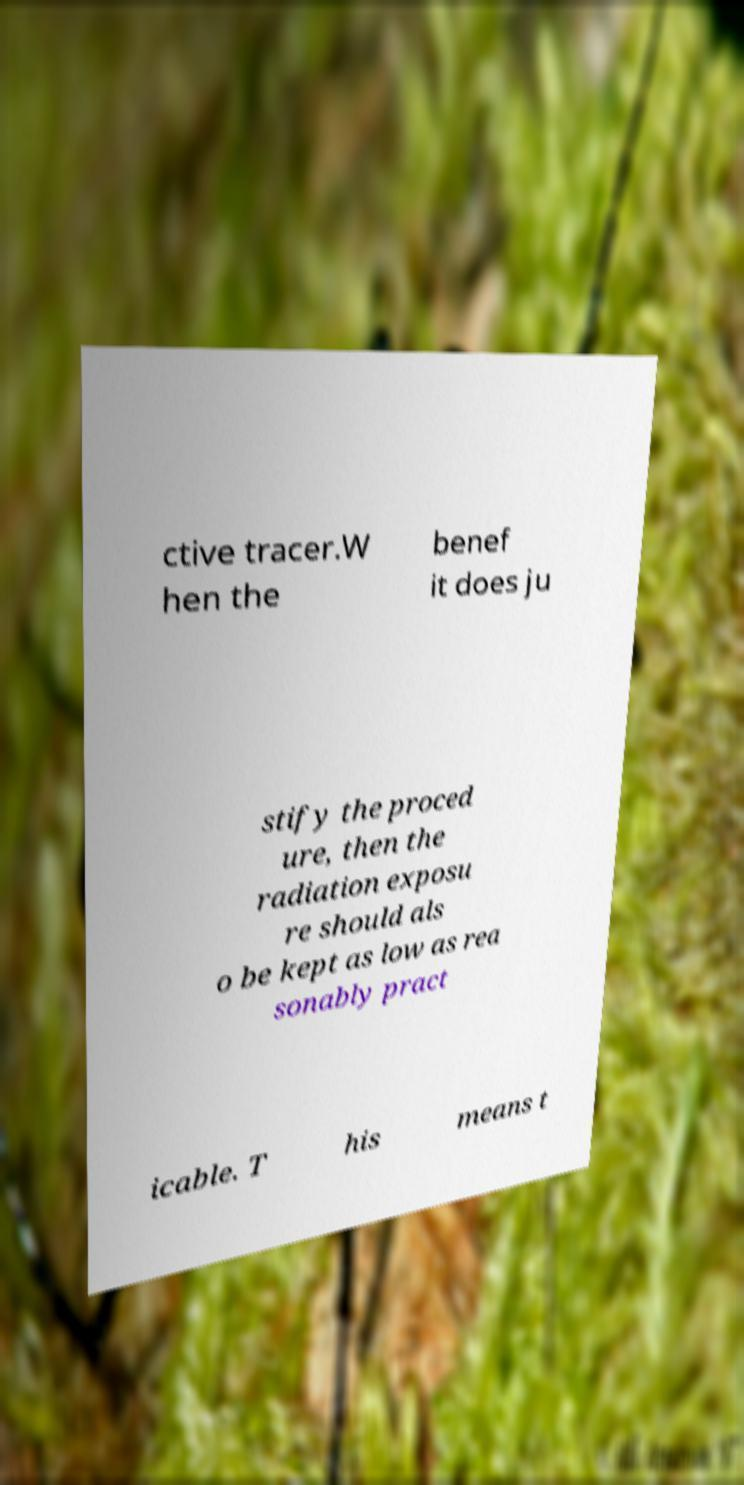Could you extract and type out the text from this image? ctive tracer.W hen the benef it does ju stify the proced ure, then the radiation exposu re should als o be kept as low as rea sonably pract icable. T his means t 